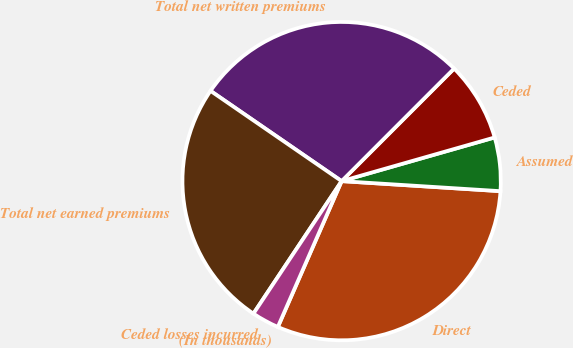<chart> <loc_0><loc_0><loc_500><loc_500><pie_chart><fcel>(In thousands)<fcel>Direct<fcel>Assumed<fcel>Ceded<fcel>Total net written premiums<fcel>Total net earned premiums<fcel>Ceded losses incurred<nl><fcel>0.01%<fcel>30.55%<fcel>5.43%<fcel>8.08%<fcel>27.9%<fcel>25.25%<fcel>2.78%<nl></chart> 